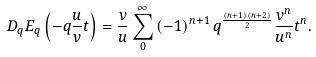Convert formula to latex. <formula><loc_0><loc_0><loc_500><loc_500>D _ { q } E _ { q } \left ( - q \frac { u } { v } t \right ) = \frac { v } { u } \sum _ { 0 } ^ { \infty } \left ( - 1 \right ) ^ { n + 1 } q ^ { \frac { \left ( n + 1 \right ) \left ( n + 2 \right ) } { 2 } } \frac { v ^ { n } } { u ^ { n } } t ^ { n } .</formula> 